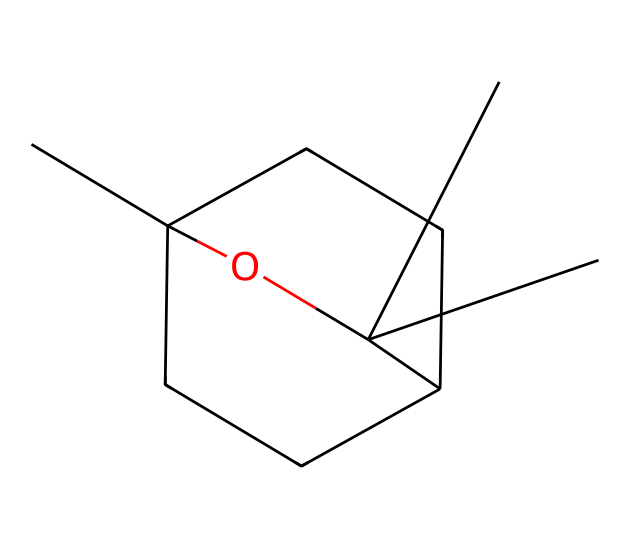What is the total number of carbon atoms in this compound? The SMILES representation indicates a total of 15 carbon atoms (C), as you can count the 'C' symbols in the structure. Each 'C' represents a carbon atom.
Answer: 15 What functional group is present in the molecule? The presence of 'O' in the SMILES suggests the molecule has a hydroxyl (-OH) functional group, typically indicating it is an alcohol.
Answer: hydroxyl How many rings are present in this chemical structure? The number '1' and '2' in the SMILES indicates the presence of two cyclic structures, which means there are 2 rings in this molecule.
Answer: 2 Is this molecule saturated or unsaturated? Given the structure and the presence of rings and oxygen, the molecule is considered to be saturated since it does not have double or triple bonds indicated by the SMILES representation.
Answer: saturated What is the molecular formula based on the SMILES? By interpreting the SMILES, the molecular formula can be derived to C15H28O. This is achieved by counting the total number of each type of atom in the structure.
Answer: C15H28O What indicates that this molecule is a hydrocarbon? The majority of the molecule consists of carbon (C) and hydrogen (H) atoms, fitting the definition of hydrocarbons, which are compounds primarily made of hydrogen and carbon.
Answer: carbon and hydrogen What kind of hydrocarbon is this compound based on its structure? Since it contains both rings and a hydroxyl group, it falls under the category of cycloalcohols, which is a type of saturated hydrocarbon.
Answer: cycloalcohol 